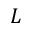<formula> <loc_0><loc_0><loc_500><loc_500>L</formula> 